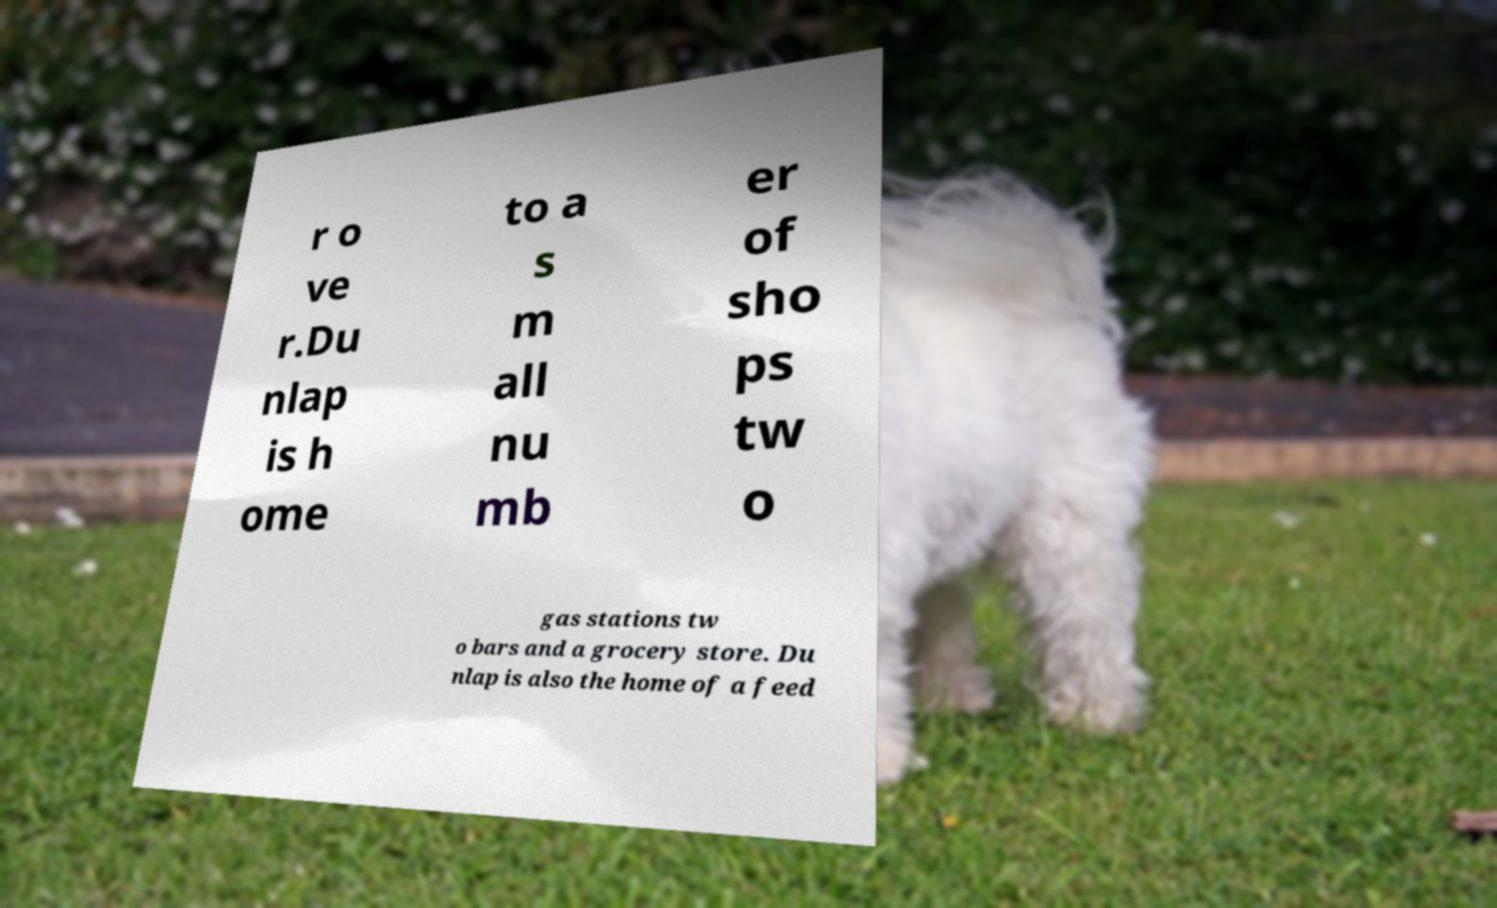Could you extract and type out the text from this image? r o ve r.Du nlap is h ome to a s m all nu mb er of sho ps tw o gas stations tw o bars and a grocery store. Du nlap is also the home of a feed 